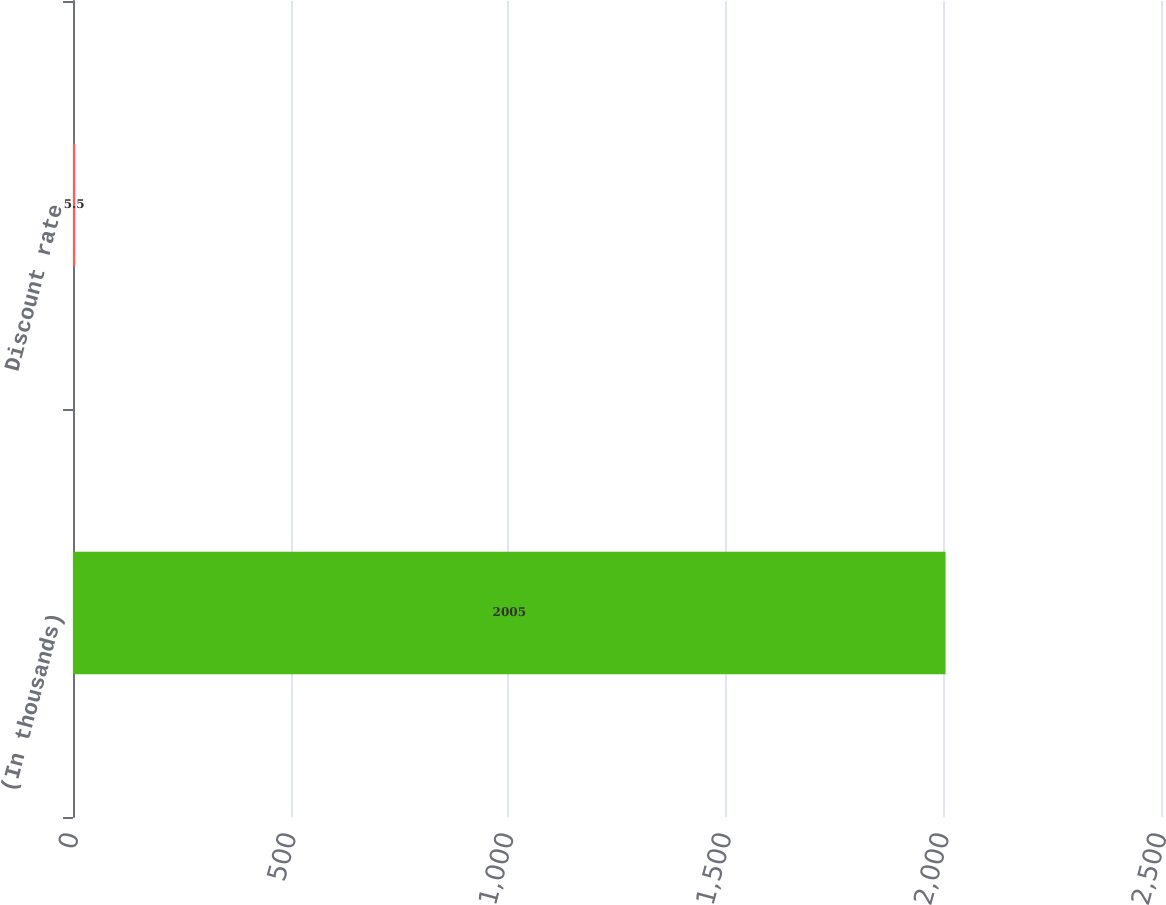Convert chart to OTSL. <chart><loc_0><loc_0><loc_500><loc_500><bar_chart><fcel>(In thousands)<fcel>Discount rate<nl><fcel>2005<fcel>5.5<nl></chart> 